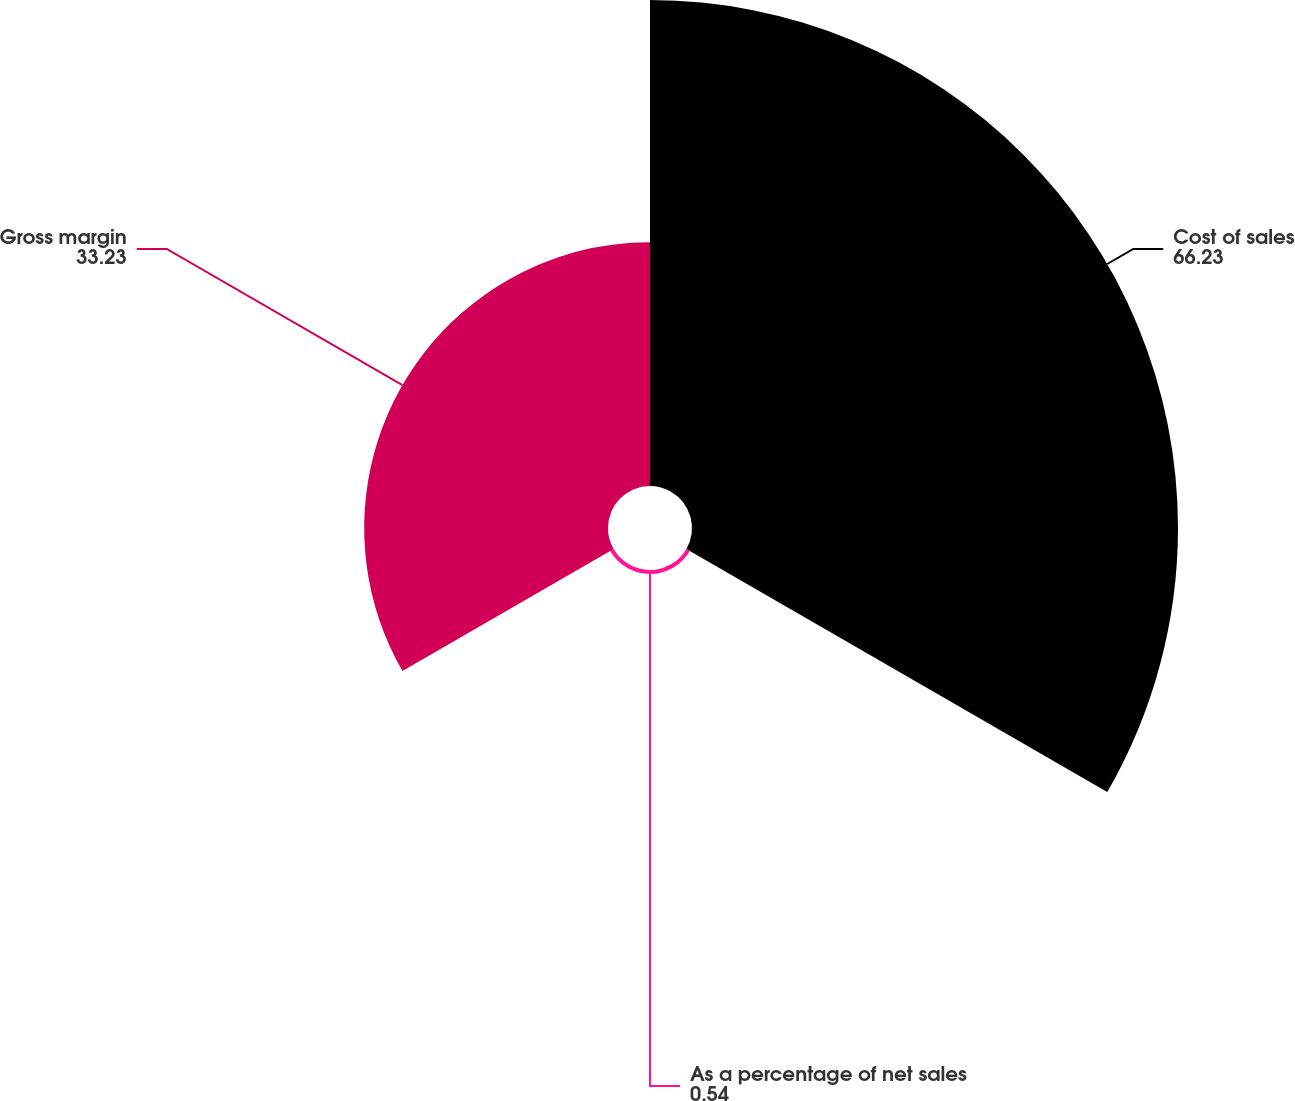<chart> <loc_0><loc_0><loc_500><loc_500><pie_chart><fcel>Cost of sales<fcel>As a percentage of net sales<fcel>Gross margin<nl><fcel>66.23%<fcel>0.54%<fcel>33.23%<nl></chart> 